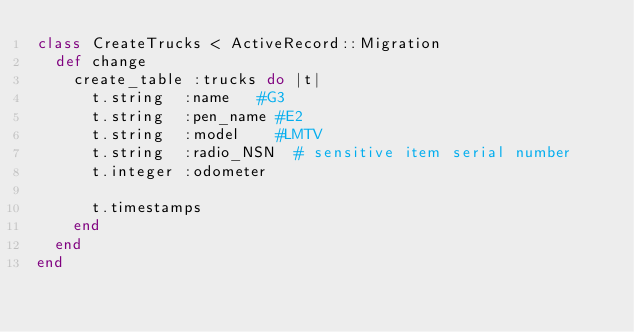<code> <loc_0><loc_0><loc_500><loc_500><_Ruby_>class CreateTrucks < ActiveRecord::Migration
  def change
    create_table :trucks do |t|
      t.string  :name   #G3
      t.string  :pen_name #E2
      t.string  :model    #LMTV
      t.string  :radio_NSN  # sensitive item serial number
      t.integer :odometer

      t.timestamps
    end
  end
end
</code> 